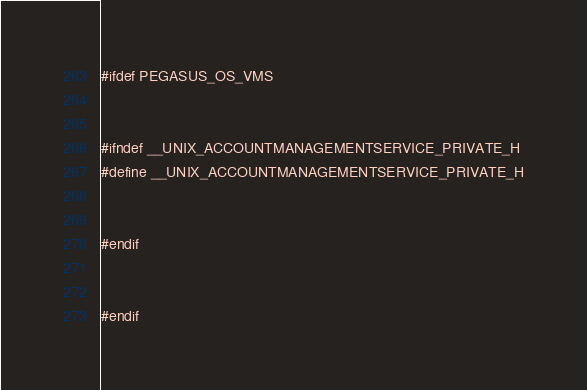<code> <loc_0><loc_0><loc_500><loc_500><_C++_>#ifdef PEGASUS_OS_VMS


#ifndef __UNIX_ACCOUNTMANAGEMENTSERVICE_PRIVATE_H
#define __UNIX_ACCOUNTMANAGEMENTSERVICE_PRIVATE_H


#endif


#endif
</code> 